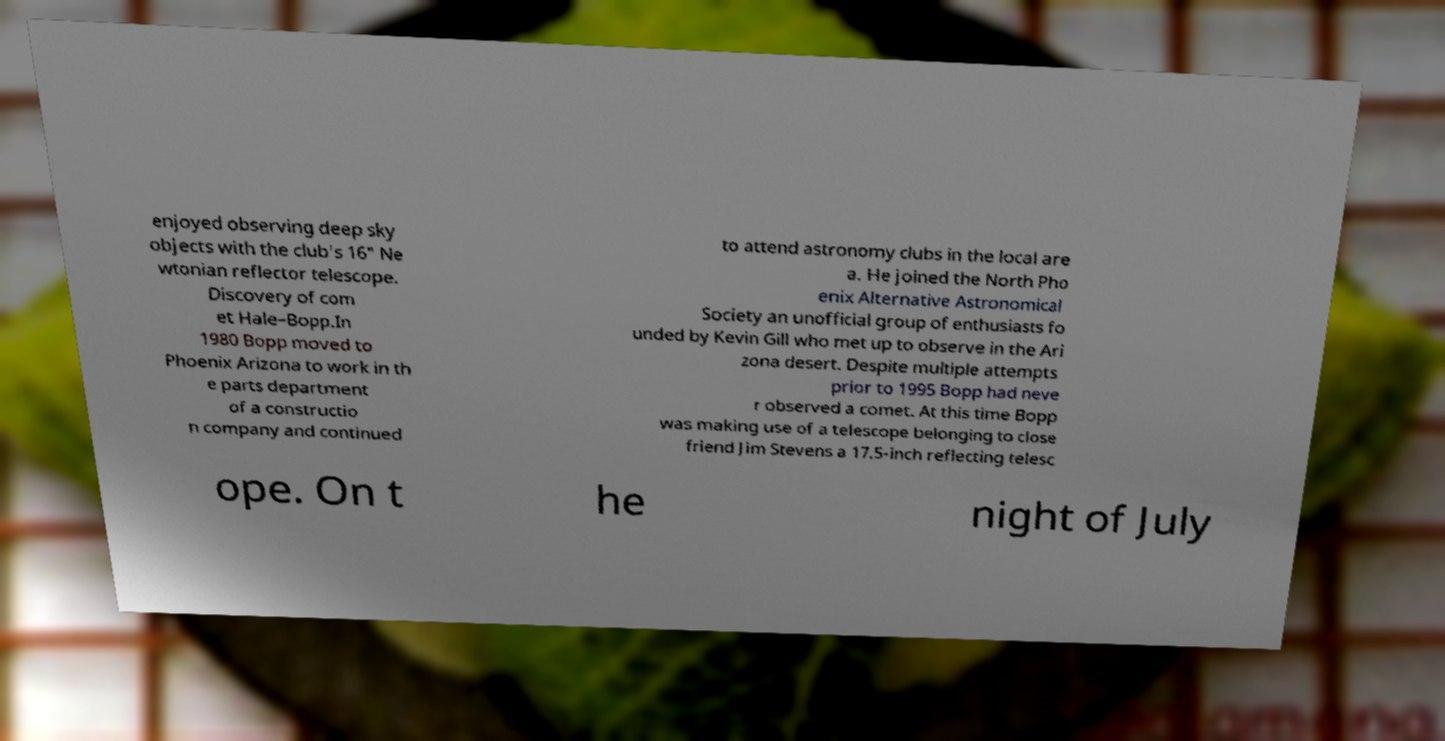Can you read and provide the text displayed in the image?This photo seems to have some interesting text. Can you extract and type it out for me? enjoyed observing deep sky objects with the club's 16" Ne wtonian reflector telescope. Discovery of com et Hale–Bopp.In 1980 Bopp moved to Phoenix Arizona to work in th e parts department of a constructio n company and continued to attend astronomy clubs in the local are a. He joined the North Pho enix Alternative Astronomical Society an unofficial group of enthusiasts fo unded by Kevin Gill who met up to observe in the Ari zona desert. Despite multiple attempts prior to 1995 Bopp had neve r observed a comet. At this time Bopp was making use of a telescope belonging to close friend Jim Stevens a 17.5-inch reflecting telesc ope. On t he night of July 